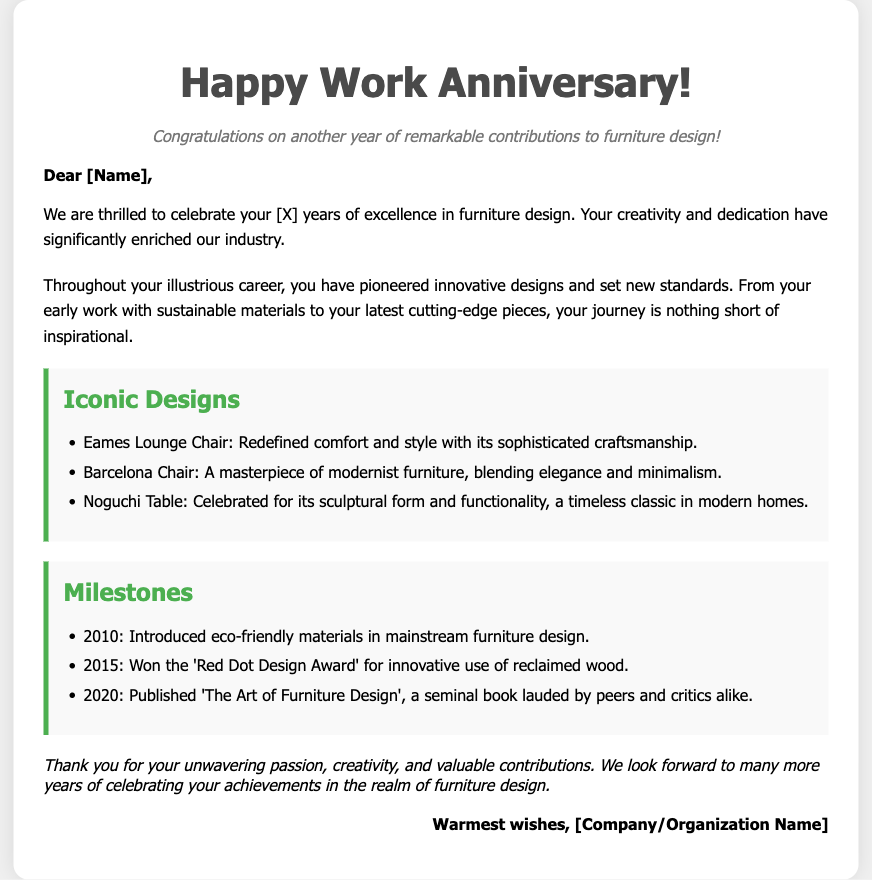What is the main purpose of the card? The card is designed to celebrate a work anniversary in the context of furniture design.
Answer: Celebrate a work anniversary Who is the recipient addressed in the card? The card addresses an individual referred to as [Name].
Answer: [Name] How many years of excellence is celebrated? The document indicates [X] years of excellence, where [X] is a placeholder for the actual number.
Answer: [X] What iconic chair is mentioned as redefining comfort? The Eames Lounge Chair is highlighted for its significant impact on comfort and style.
Answer: Eames Lounge Chair Which prestigious award did the recipient win in 2015? The card mentions the 'Red Dot Design Award' awarded in 2015 for innovative design.
Answer: Red Dot Design Award What book did the recipient publish in 2020? The book published is titled 'The Art of Furniture Design,' recognized for its contribution to the field.
Answer: The Art of Furniture Design What is a key theme throughout the card? The card emphasizes the recipient's creativity and dedication in the field of furniture design.
Answer: Creativity and dedication Which material approach did the recipient introduce in 2010? The document states that eco-friendly materials were introduced in mainstream furniture design.
Answer: Eco-friendly materials What type of text style is used for the greeting? The greeting text is italicized to convey a warm and celebratory tone.
Answer: Italicized 